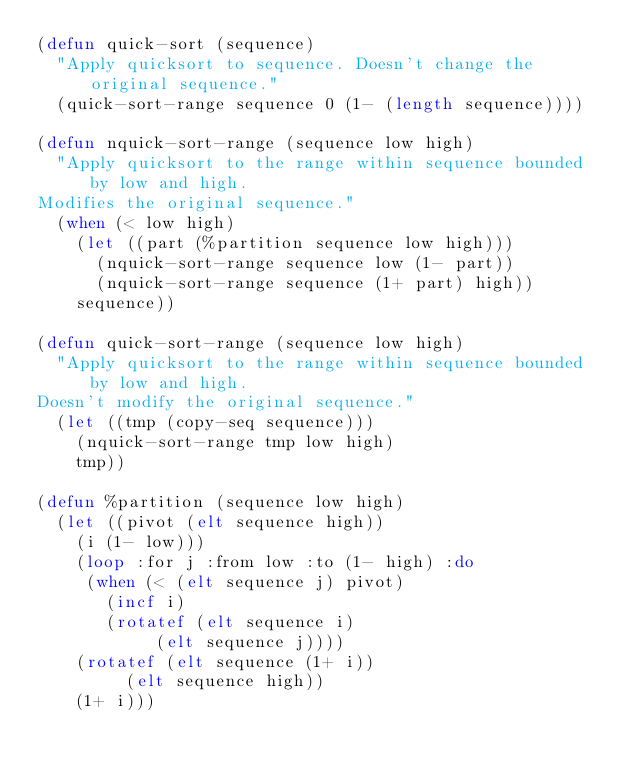Convert code to text. <code><loc_0><loc_0><loc_500><loc_500><_Lisp_>(defun quick-sort (sequence)
  "Apply quicksort to sequence. Doesn't change the original sequence."
  (quick-sort-range sequence 0 (1- (length sequence))))

(defun nquick-sort-range (sequence low high)
  "Apply quicksort to the range within sequence bounded by low and high.
Modifies the original sequence."
  (when (< low high)
    (let ((part (%partition sequence low high)))
      (nquick-sort-range sequence low (1- part))
      (nquick-sort-range sequence (1+ part) high))
    sequence))

(defun quick-sort-range (sequence low high)
  "Apply quicksort to the range within sequence bounded by low and high.
Doesn't modify the original sequence."
  (let ((tmp (copy-seq sequence)))
    (nquick-sort-range tmp low high)
    tmp))

(defun %partition (sequence low high)
  (let ((pivot (elt sequence high))
	(i (1- low)))
    (loop :for j :from low :to (1- high) :do
	 (when (< (elt sequence j) pivot)
	   (incf i)
	   (rotatef (elt sequence i)
		    (elt sequence j))))
    (rotatef (elt sequence (1+ i))
	     (elt sequence high))
    (1+ i)))
</code> 